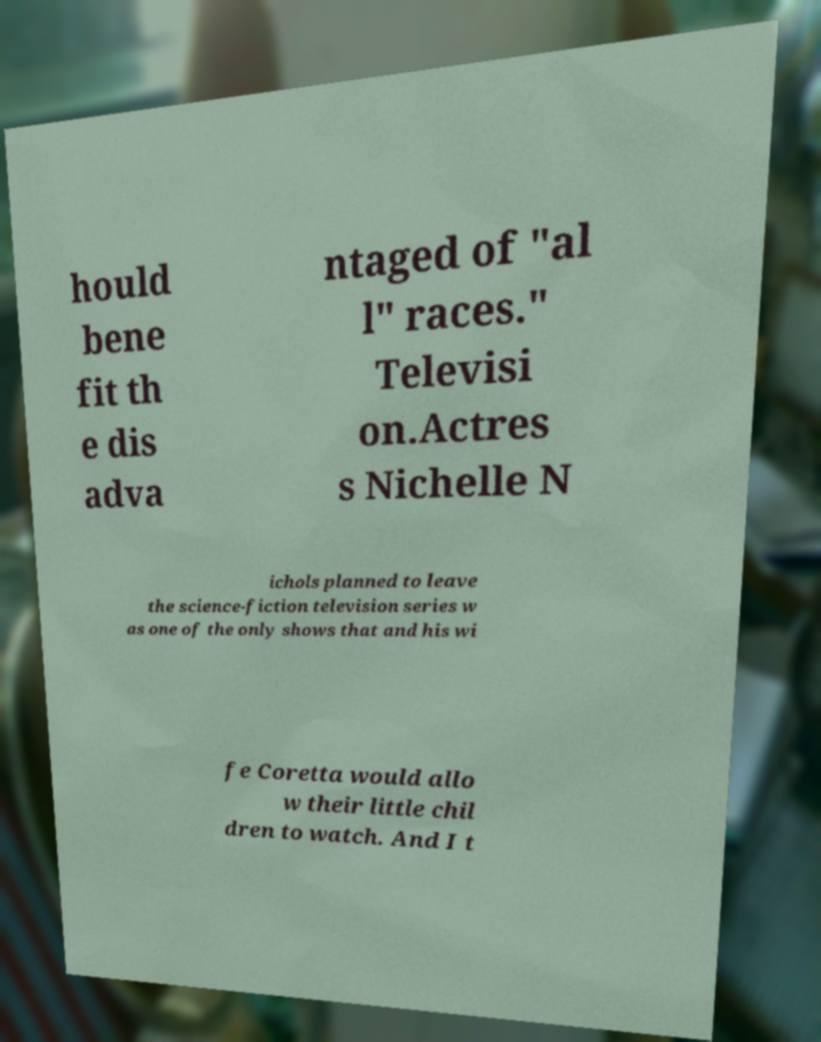Can you read and provide the text displayed in the image?This photo seems to have some interesting text. Can you extract and type it out for me? hould bene fit th e dis adva ntaged of "al l" races." Televisi on.Actres s Nichelle N ichols planned to leave the science-fiction television series w as one of the only shows that and his wi fe Coretta would allo w their little chil dren to watch. And I t 